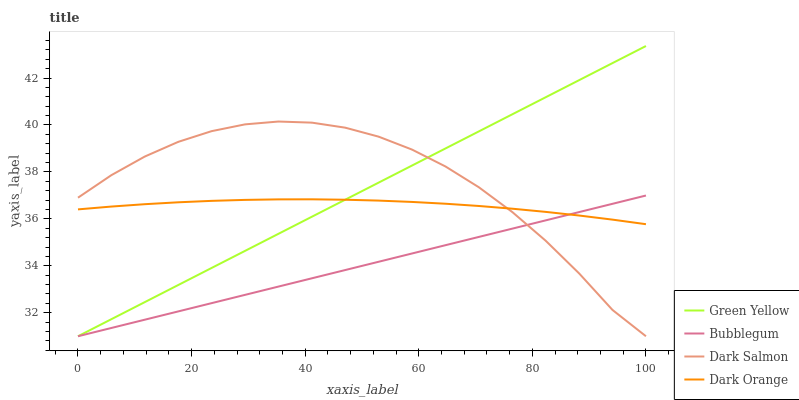Does Bubblegum have the minimum area under the curve?
Answer yes or no. Yes. Does Dark Salmon have the maximum area under the curve?
Answer yes or no. Yes. Does Green Yellow have the minimum area under the curve?
Answer yes or no. No. Does Green Yellow have the maximum area under the curve?
Answer yes or no. No. Is Green Yellow the smoothest?
Answer yes or no. Yes. Is Dark Salmon the roughest?
Answer yes or no. Yes. Is Dark Salmon the smoothest?
Answer yes or no. No. Is Green Yellow the roughest?
Answer yes or no. No. Does Green Yellow have the lowest value?
Answer yes or no. Yes. Does Green Yellow have the highest value?
Answer yes or no. Yes. Does Dark Salmon have the highest value?
Answer yes or no. No. Does Bubblegum intersect Dark Orange?
Answer yes or no. Yes. Is Bubblegum less than Dark Orange?
Answer yes or no. No. Is Bubblegum greater than Dark Orange?
Answer yes or no. No. 